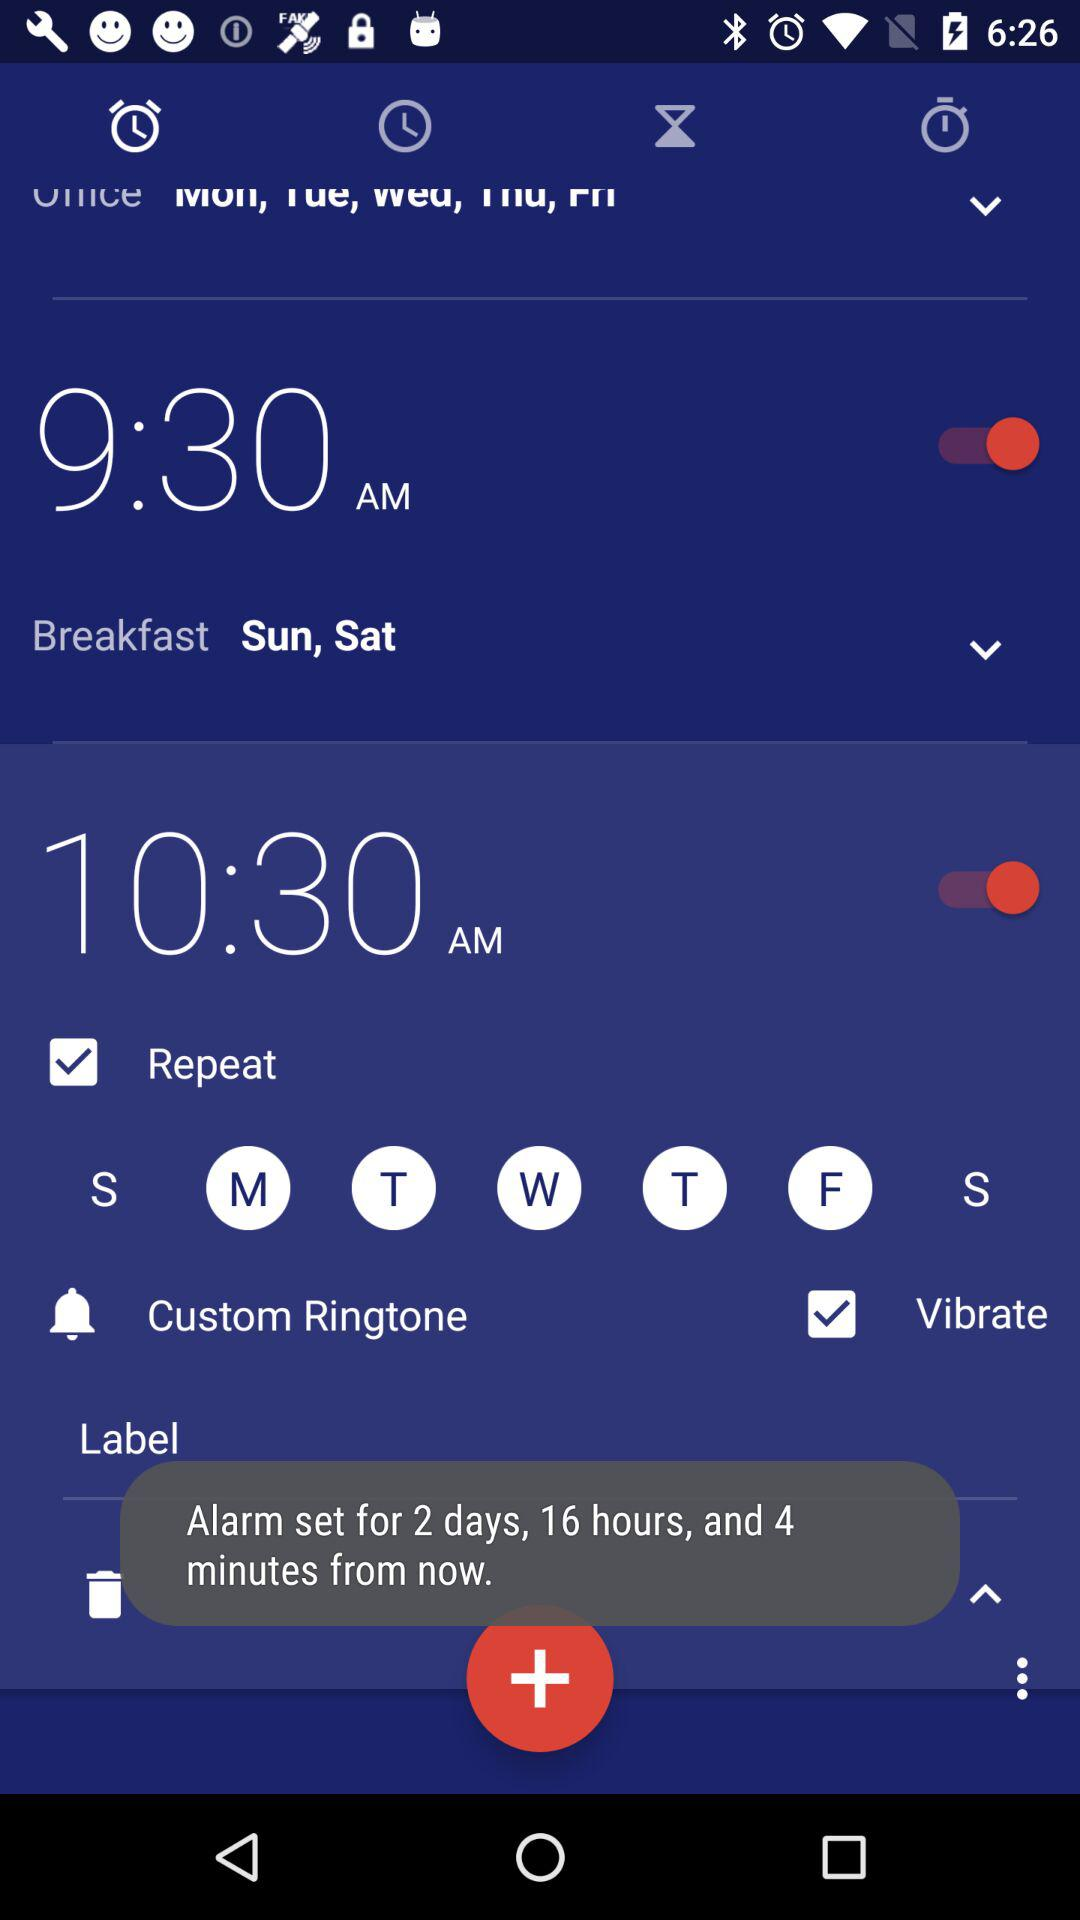What is the status of 9:30 am? The status is on. 